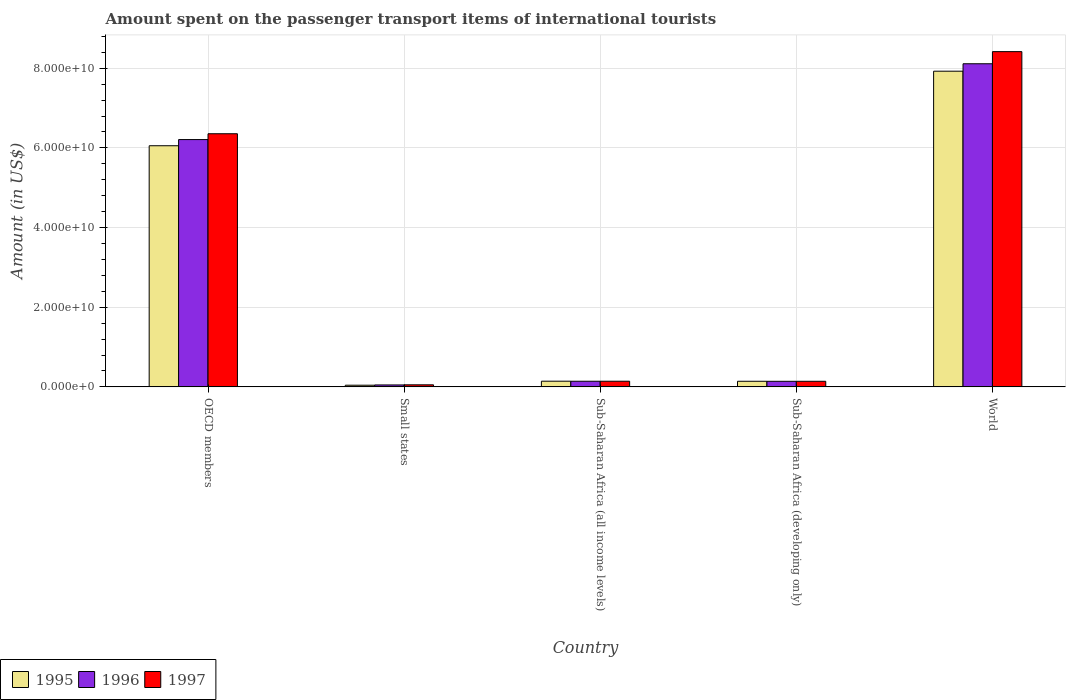How many groups of bars are there?
Your response must be concise. 5. Are the number of bars per tick equal to the number of legend labels?
Offer a very short reply. Yes. Are the number of bars on each tick of the X-axis equal?
Your response must be concise. Yes. How many bars are there on the 5th tick from the left?
Your answer should be very brief. 3. What is the amount spent on the passenger transport items of international tourists in 1996 in Sub-Saharan Africa (all income levels)?
Make the answer very short. 1.41e+09. Across all countries, what is the maximum amount spent on the passenger transport items of international tourists in 1995?
Give a very brief answer. 7.93e+1. Across all countries, what is the minimum amount spent on the passenger transport items of international tourists in 1995?
Provide a short and direct response. 4.15e+08. In which country was the amount spent on the passenger transport items of international tourists in 1997 minimum?
Your answer should be compact. Small states. What is the total amount spent on the passenger transport items of international tourists in 1996 in the graph?
Ensure brevity in your answer.  1.47e+11. What is the difference between the amount spent on the passenger transport items of international tourists in 1997 in OECD members and that in Small states?
Provide a short and direct response. 6.30e+1. What is the difference between the amount spent on the passenger transport items of international tourists in 1996 in World and the amount spent on the passenger transport items of international tourists in 1997 in Small states?
Provide a short and direct response. 8.06e+1. What is the average amount spent on the passenger transport items of international tourists in 1997 per country?
Your answer should be compact. 3.02e+1. What is the difference between the amount spent on the passenger transport items of international tourists of/in 1995 and amount spent on the passenger transport items of international tourists of/in 1997 in World?
Your answer should be compact. -4.91e+09. What is the ratio of the amount spent on the passenger transport items of international tourists in 1996 in OECD members to that in World?
Your answer should be compact. 0.77. Is the amount spent on the passenger transport items of international tourists in 1995 in Sub-Saharan Africa (all income levels) less than that in Sub-Saharan Africa (developing only)?
Provide a succinct answer. No. What is the difference between the highest and the second highest amount spent on the passenger transport items of international tourists in 1996?
Your response must be concise. 6.07e+1. What is the difference between the highest and the lowest amount spent on the passenger transport items of international tourists in 1997?
Your answer should be compact. 8.36e+1. Is the sum of the amount spent on the passenger transport items of international tourists in 1996 in OECD members and Sub-Saharan Africa (developing only) greater than the maximum amount spent on the passenger transport items of international tourists in 1997 across all countries?
Your answer should be compact. No. What does the 3rd bar from the right in Small states represents?
Give a very brief answer. 1995. Is it the case that in every country, the sum of the amount spent on the passenger transport items of international tourists in 1995 and amount spent on the passenger transport items of international tourists in 1997 is greater than the amount spent on the passenger transport items of international tourists in 1996?
Your answer should be compact. Yes. How many bars are there?
Ensure brevity in your answer.  15. Are the values on the major ticks of Y-axis written in scientific E-notation?
Your answer should be compact. Yes. Does the graph contain grids?
Offer a very short reply. Yes. Where does the legend appear in the graph?
Keep it short and to the point. Bottom left. How many legend labels are there?
Give a very brief answer. 3. What is the title of the graph?
Your answer should be very brief. Amount spent on the passenger transport items of international tourists. What is the label or title of the Y-axis?
Offer a very short reply. Amount (in US$). What is the Amount (in US$) in 1995 in OECD members?
Your answer should be compact. 6.05e+1. What is the Amount (in US$) of 1996 in OECD members?
Your answer should be compact. 6.21e+1. What is the Amount (in US$) in 1997 in OECD members?
Offer a terse response. 6.35e+1. What is the Amount (in US$) of 1995 in Small states?
Ensure brevity in your answer.  4.15e+08. What is the Amount (in US$) of 1996 in Small states?
Make the answer very short. 4.85e+08. What is the Amount (in US$) of 1997 in Small states?
Ensure brevity in your answer.  5.15e+08. What is the Amount (in US$) of 1995 in Sub-Saharan Africa (all income levels)?
Provide a short and direct response. 1.42e+09. What is the Amount (in US$) of 1996 in Sub-Saharan Africa (all income levels)?
Provide a succinct answer. 1.41e+09. What is the Amount (in US$) in 1997 in Sub-Saharan Africa (all income levels)?
Ensure brevity in your answer.  1.42e+09. What is the Amount (in US$) in 1995 in Sub-Saharan Africa (developing only)?
Offer a very short reply. 1.41e+09. What is the Amount (in US$) of 1996 in Sub-Saharan Africa (developing only)?
Your response must be concise. 1.40e+09. What is the Amount (in US$) in 1997 in Sub-Saharan Africa (developing only)?
Make the answer very short. 1.40e+09. What is the Amount (in US$) in 1995 in World?
Keep it short and to the point. 7.93e+1. What is the Amount (in US$) in 1996 in World?
Give a very brief answer. 8.11e+1. What is the Amount (in US$) of 1997 in World?
Ensure brevity in your answer.  8.42e+1. Across all countries, what is the maximum Amount (in US$) in 1995?
Keep it short and to the point. 7.93e+1. Across all countries, what is the maximum Amount (in US$) of 1996?
Your answer should be very brief. 8.11e+1. Across all countries, what is the maximum Amount (in US$) in 1997?
Keep it short and to the point. 8.42e+1. Across all countries, what is the minimum Amount (in US$) of 1995?
Offer a very short reply. 4.15e+08. Across all countries, what is the minimum Amount (in US$) in 1996?
Provide a short and direct response. 4.85e+08. Across all countries, what is the minimum Amount (in US$) in 1997?
Your response must be concise. 5.15e+08. What is the total Amount (in US$) of 1995 in the graph?
Offer a very short reply. 1.43e+11. What is the total Amount (in US$) in 1996 in the graph?
Your answer should be compact. 1.47e+11. What is the total Amount (in US$) of 1997 in the graph?
Offer a terse response. 1.51e+11. What is the difference between the Amount (in US$) of 1995 in OECD members and that in Small states?
Keep it short and to the point. 6.01e+1. What is the difference between the Amount (in US$) of 1996 in OECD members and that in Small states?
Ensure brevity in your answer.  6.16e+1. What is the difference between the Amount (in US$) in 1997 in OECD members and that in Small states?
Your answer should be compact. 6.30e+1. What is the difference between the Amount (in US$) in 1995 in OECD members and that in Sub-Saharan Africa (all income levels)?
Keep it short and to the point. 5.91e+1. What is the difference between the Amount (in US$) of 1996 in OECD members and that in Sub-Saharan Africa (all income levels)?
Keep it short and to the point. 6.07e+1. What is the difference between the Amount (in US$) of 1997 in OECD members and that in Sub-Saharan Africa (all income levels)?
Offer a terse response. 6.21e+1. What is the difference between the Amount (in US$) of 1995 in OECD members and that in Sub-Saharan Africa (developing only)?
Make the answer very short. 5.91e+1. What is the difference between the Amount (in US$) in 1996 in OECD members and that in Sub-Saharan Africa (developing only)?
Offer a very short reply. 6.07e+1. What is the difference between the Amount (in US$) in 1997 in OECD members and that in Sub-Saharan Africa (developing only)?
Keep it short and to the point. 6.21e+1. What is the difference between the Amount (in US$) in 1995 in OECD members and that in World?
Offer a very short reply. -1.87e+1. What is the difference between the Amount (in US$) of 1996 in OECD members and that in World?
Provide a short and direct response. -1.90e+1. What is the difference between the Amount (in US$) of 1997 in OECD members and that in World?
Ensure brevity in your answer.  -2.06e+1. What is the difference between the Amount (in US$) of 1995 in Small states and that in Sub-Saharan Africa (all income levels)?
Provide a succinct answer. -1.01e+09. What is the difference between the Amount (in US$) of 1996 in Small states and that in Sub-Saharan Africa (all income levels)?
Give a very brief answer. -9.28e+08. What is the difference between the Amount (in US$) in 1997 in Small states and that in Sub-Saharan Africa (all income levels)?
Provide a succinct answer. -9.01e+08. What is the difference between the Amount (in US$) in 1995 in Small states and that in Sub-Saharan Africa (developing only)?
Provide a succinct answer. -9.90e+08. What is the difference between the Amount (in US$) in 1996 in Small states and that in Sub-Saharan Africa (developing only)?
Your response must be concise. -9.14e+08. What is the difference between the Amount (in US$) of 1997 in Small states and that in Sub-Saharan Africa (developing only)?
Provide a short and direct response. -8.87e+08. What is the difference between the Amount (in US$) in 1995 in Small states and that in World?
Your answer should be very brief. -7.88e+1. What is the difference between the Amount (in US$) of 1996 in Small states and that in World?
Ensure brevity in your answer.  -8.06e+1. What is the difference between the Amount (in US$) of 1997 in Small states and that in World?
Ensure brevity in your answer.  -8.36e+1. What is the difference between the Amount (in US$) in 1995 in Sub-Saharan Africa (all income levels) and that in Sub-Saharan Africa (developing only)?
Your answer should be very brief. 1.78e+07. What is the difference between the Amount (in US$) in 1996 in Sub-Saharan Africa (all income levels) and that in Sub-Saharan Africa (developing only)?
Offer a terse response. 1.43e+07. What is the difference between the Amount (in US$) in 1997 in Sub-Saharan Africa (all income levels) and that in Sub-Saharan Africa (developing only)?
Your answer should be very brief. 1.43e+07. What is the difference between the Amount (in US$) in 1995 in Sub-Saharan Africa (all income levels) and that in World?
Give a very brief answer. -7.78e+1. What is the difference between the Amount (in US$) of 1996 in Sub-Saharan Africa (all income levels) and that in World?
Keep it short and to the point. -7.97e+1. What is the difference between the Amount (in US$) of 1997 in Sub-Saharan Africa (all income levels) and that in World?
Provide a short and direct response. -8.27e+1. What is the difference between the Amount (in US$) in 1995 in Sub-Saharan Africa (developing only) and that in World?
Offer a very short reply. -7.78e+1. What is the difference between the Amount (in US$) of 1996 in Sub-Saharan Africa (developing only) and that in World?
Offer a very short reply. -7.97e+1. What is the difference between the Amount (in US$) of 1997 in Sub-Saharan Africa (developing only) and that in World?
Give a very brief answer. -8.28e+1. What is the difference between the Amount (in US$) of 1995 in OECD members and the Amount (in US$) of 1996 in Small states?
Your answer should be compact. 6.01e+1. What is the difference between the Amount (in US$) in 1995 in OECD members and the Amount (in US$) in 1997 in Small states?
Keep it short and to the point. 6.00e+1. What is the difference between the Amount (in US$) of 1996 in OECD members and the Amount (in US$) of 1997 in Small states?
Make the answer very short. 6.16e+1. What is the difference between the Amount (in US$) in 1995 in OECD members and the Amount (in US$) in 1996 in Sub-Saharan Africa (all income levels)?
Offer a terse response. 5.91e+1. What is the difference between the Amount (in US$) of 1995 in OECD members and the Amount (in US$) of 1997 in Sub-Saharan Africa (all income levels)?
Provide a succinct answer. 5.91e+1. What is the difference between the Amount (in US$) of 1996 in OECD members and the Amount (in US$) of 1997 in Sub-Saharan Africa (all income levels)?
Ensure brevity in your answer.  6.07e+1. What is the difference between the Amount (in US$) in 1995 in OECD members and the Amount (in US$) in 1996 in Sub-Saharan Africa (developing only)?
Your answer should be very brief. 5.91e+1. What is the difference between the Amount (in US$) in 1995 in OECD members and the Amount (in US$) in 1997 in Sub-Saharan Africa (developing only)?
Make the answer very short. 5.91e+1. What is the difference between the Amount (in US$) of 1996 in OECD members and the Amount (in US$) of 1997 in Sub-Saharan Africa (developing only)?
Ensure brevity in your answer.  6.07e+1. What is the difference between the Amount (in US$) in 1995 in OECD members and the Amount (in US$) in 1996 in World?
Your response must be concise. -2.06e+1. What is the difference between the Amount (in US$) in 1995 in OECD members and the Amount (in US$) in 1997 in World?
Provide a short and direct response. -2.36e+1. What is the difference between the Amount (in US$) in 1996 in OECD members and the Amount (in US$) in 1997 in World?
Provide a succinct answer. -2.21e+1. What is the difference between the Amount (in US$) of 1995 in Small states and the Amount (in US$) of 1996 in Sub-Saharan Africa (all income levels)?
Ensure brevity in your answer.  -9.98e+08. What is the difference between the Amount (in US$) in 1995 in Small states and the Amount (in US$) in 1997 in Sub-Saharan Africa (all income levels)?
Offer a very short reply. -1.00e+09. What is the difference between the Amount (in US$) of 1996 in Small states and the Amount (in US$) of 1997 in Sub-Saharan Africa (all income levels)?
Your answer should be compact. -9.31e+08. What is the difference between the Amount (in US$) of 1995 in Small states and the Amount (in US$) of 1996 in Sub-Saharan Africa (developing only)?
Provide a short and direct response. -9.84e+08. What is the difference between the Amount (in US$) in 1995 in Small states and the Amount (in US$) in 1997 in Sub-Saharan Africa (developing only)?
Provide a succinct answer. -9.86e+08. What is the difference between the Amount (in US$) in 1996 in Small states and the Amount (in US$) in 1997 in Sub-Saharan Africa (developing only)?
Make the answer very short. -9.17e+08. What is the difference between the Amount (in US$) of 1995 in Small states and the Amount (in US$) of 1996 in World?
Provide a short and direct response. -8.07e+1. What is the difference between the Amount (in US$) of 1995 in Small states and the Amount (in US$) of 1997 in World?
Keep it short and to the point. -8.37e+1. What is the difference between the Amount (in US$) in 1996 in Small states and the Amount (in US$) in 1997 in World?
Give a very brief answer. -8.37e+1. What is the difference between the Amount (in US$) of 1995 in Sub-Saharan Africa (all income levels) and the Amount (in US$) of 1996 in Sub-Saharan Africa (developing only)?
Your answer should be compact. 2.39e+07. What is the difference between the Amount (in US$) in 1995 in Sub-Saharan Africa (all income levels) and the Amount (in US$) in 1997 in Sub-Saharan Africa (developing only)?
Provide a short and direct response. 2.14e+07. What is the difference between the Amount (in US$) of 1996 in Sub-Saharan Africa (all income levels) and the Amount (in US$) of 1997 in Sub-Saharan Africa (developing only)?
Keep it short and to the point. 1.18e+07. What is the difference between the Amount (in US$) in 1995 in Sub-Saharan Africa (all income levels) and the Amount (in US$) in 1996 in World?
Ensure brevity in your answer.  -7.97e+1. What is the difference between the Amount (in US$) in 1995 in Sub-Saharan Africa (all income levels) and the Amount (in US$) in 1997 in World?
Your answer should be compact. -8.27e+1. What is the difference between the Amount (in US$) of 1996 in Sub-Saharan Africa (all income levels) and the Amount (in US$) of 1997 in World?
Provide a succinct answer. -8.27e+1. What is the difference between the Amount (in US$) of 1995 in Sub-Saharan Africa (developing only) and the Amount (in US$) of 1996 in World?
Provide a succinct answer. -7.97e+1. What is the difference between the Amount (in US$) of 1995 in Sub-Saharan Africa (developing only) and the Amount (in US$) of 1997 in World?
Offer a terse response. -8.28e+1. What is the difference between the Amount (in US$) of 1996 in Sub-Saharan Africa (developing only) and the Amount (in US$) of 1997 in World?
Make the answer very short. -8.28e+1. What is the average Amount (in US$) in 1995 per country?
Make the answer very short. 2.86e+1. What is the average Amount (in US$) of 1996 per country?
Give a very brief answer. 2.93e+1. What is the average Amount (in US$) in 1997 per country?
Provide a short and direct response. 3.02e+1. What is the difference between the Amount (in US$) in 1995 and Amount (in US$) in 1996 in OECD members?
Offer a terse response. -1.55e+09. What is the difference between the Amount (in US$) of 1995 and Amount (in US$) of 1997 in OECD members?
Offer a very short reply. -3.01e+09. What is the difference between the Amount (in US$) of 1996 and Amount (in US$) of 1997 in OECD members?
Provide a short and direct response. -1.46e+09. What is the difference between the Amount (in US$) in 1995 and Amount (in US$) in 1996 in Small states?
Provide a short and direct response. -6.97e+07. What is the difference between the Amount (in US$) of 1995 and Amount (in US$) of 1997 in Small states?
Give a very brief answer. -9.94e+07. What is the difference between the Amount (in US$) of 1996 and Amount (in US$) of 1997 in Small states?
Keep it short and to the point. -2.97e+07. What is the difference between the Amount (in US$) of 1995 and Amount (in US$) of 1996 in Sub-Saharan Africa (all income levels)?
Make the answer very short. 9.58e+06. What is the difference between the Amount (in US$) in 1995 and Amount (in US$) in 1997 in Sub-Saharan Africa (all income levels)?
Provide a short and direct response. 7.08e+06. What is the difference between the Amount (in US$) in 1996 and Amount (in US$) in 1997 in Sub-Saharan Africa (all income levels)?
Your response must be concise. -2.51e+06. What is the difference between the Amount (in US$) in 1995 and Amount (in US$) in 1996 in Sub-Saharan Africa (developing only)?
Provide a short and direct response. 6.01e+06. What is the difference between the Amount (in US$) of 1995 and Amount (in US$) of 1997 in Sub-Saharan Africa (developing only)?
Make the answer very short. 3.52e+06. What is the difference between the Amount (in US$) of 1996 and Amount (in US$) of 1997 in Sub-Saharan Africa (developing only)?
Keep it short and to the point. -2.49e+06. What is the difference between the Amount (in US$) in 1995 and Amount (in US$) in 1996 in World?
Keep it short and to the point. -1.87e+09. What is the difference between the Amount (in US$) in 1995 and Amount (in US$) in 1997 in World?
Provide a succinct answer. -4.91e+09. What is the difference between the Amount (in US$) of 1996 and Amount (in US$) of 1997 in World?
Your answer should be compact. -3.04e+09. What is the ratio of the Amount (in US$) in 1995 in OECD members to that in Small states?
Offer a very short reply. 145.72. What is the ratio of the Amount (in US$) in 1996 in OECD members to that in Small states?
Provide a succinct answer. 127.96. What is the ratio of the Amount (in US$) of 1997 in OECD members to that in Small states?
Provide a succinct answer. 123.42. What is the ratio of the Amount (in US$) in 1995 in OECD members to that in Sub-Saharan Africa (all income levels)?
Offer a terse response. 42.54. What is the ratio of the Amount (in US$) of 1996 in OECD members to that in Sub-Saharan Africa (all income levels)?
Offer a terse response. 43.92. What is the ratio of the Amount (in US$) in 1997 in OECD members to that in Sub-Saharan Africa (all income levels)?
Your answer should be compact. 44.87. What is the ratio of the Amount (in US$) in 1995 in OECD members to that in Sub-Saharan Africa (developing only)?
Give a very brief answer. 43.08. What is the ratio of the Amount (in US$) in 1996 in OECD members to that in Sub-Saharan Africa (developing only)?
Your answer should be very brief. 44.37. What is the ratio of the Amount (in US$) of 1997 in OECD members to that in Sub-Saharan Africa (developing only)?
Give a very brief answer. 45.33. What is the ratio of the Amount (in US$) of 1995 in OECD members to that in World?
Give a very brief answer. 0.76. What is the ratio of the Amount (in US$) in 1996 in OECD members to that in World?
Provide a short and direct response. 0.77. What is the ratio of the Amount (in US$) in 1997 in OECD members to that in World?
Ensure brevity in your answer.  0.76. What is the ratio of the Amount (in US$) in 1995 in Small states to that in Sub-Saharan Africa (all income levels)?
Make the answer very short. 0.29. What is the ratio of the Amount (in US$) in 1996 in Small states to that in Sub-Saharan Africa (all income levels)?
Your answer should be very brief. 0.34. What is the ratio of the Amount (in US$) in 1997 in Small states to that in Sub-Saharan Africa (all income levels)?
Provide a succinct answer. 0.36. What is the ratio of the Amount (in US$) of 1995 in Small states to that in Sub-Saharan Africa (developing only)?
Your answer should be compact. 0.3. What is the ratio of the Amount (in US$) in 1996 in Small states to that in Sub-Saharan Africa (developing only)?
Offer a terse response. 0.35. What is the ratio of the Amount (in US$) in 1997 in Small states to that in Sub-Saharan Africa (developing only)?
Give a very brief answer. 0.37. What is the ratio of the Amount (in US$) in 1995 in Small states to that in World?
Give a very brief answer. 0.01. What is the ratio of the Amount (in US$) of 1996 in Small states to that in World?
Provide a short and direct response. 0.01. What is the ratio of the Amount (in US$) in 1997 in Small states to that in World?
Ensure brevity in your answer.  0.01. What is the ratio of the Amount (in US$) of 1995 in Sub-Saharan Africa (all income levels) to that in Sub-Saharan Africa (developing only)?
Ensure brevity in your answer.  1.01. What is the ratio of the Amount (in US$) in 1996 in Sub-Saharan Africa (all income levels) to that in Sub-Saharan Africa (developing only)?
Offer a very short reply. 1.01. What is the ratio of the Amount (in US$) in 1997 in Sub-Saharan Africa (all income levels) to that in Sub-Saharan Africa (developing only)?
Keep it short and to the point. 1.01. What is the ratio of the Amount (in US$) of 1995 in Sub-Saharan Africa (all income levels) to that in World?
Offer a terse response. 0.02. What is the ratio of the Amount (in US$) in 1996 in Sub-Saharan Africa (all income levels) to that in World?
Provide a short and direct response. 0.02. What is the ratio of the Amount (in US$) of 1997 in Sub-Saharan Africa (all income levels) to that in World?
Provide a succinct answer. 0.02. What is the ratio of the Amount (in US$) of 1995 in Sub-Saharan Africa (developing only) to that in World?
Offer a very short reply. 0.02. What is the ratio of the Amount (in US$) in 1996 in Sub-Saharan Africa (developing only) to that in World?
Give a very brief answer. 0.02. What is the ratio of the Amount (in US$) of 1997 in Sub-Saharan Africa (developing only) to that in World?
Provide a short and direct response. 0.02. What is the difference between the highest and the second highest Amount (in US$) of 1995?
Give a very brief answer. 1.87e+1. What is the difference between the highest and the second highest Amount (in US$) in 1996?
Your response must be concise. 1.90e+1. What is the difference between the highest and the second highest Amount (in US$) in 1997?
Your response must be concise. 2.06e+1. What is the difference between the highest and the lowest Amount (in US$) of 1995?
Offer a terse response. 7.88e+1. What is the difference between the highest and the lowest Amount (in US$) of 1996?
Offer a very short reply. 8.06e+1. What is the difference between the highest and the lowest Amount (in US$) in 1997?
Give a very brief answer. 8.36e+1. 